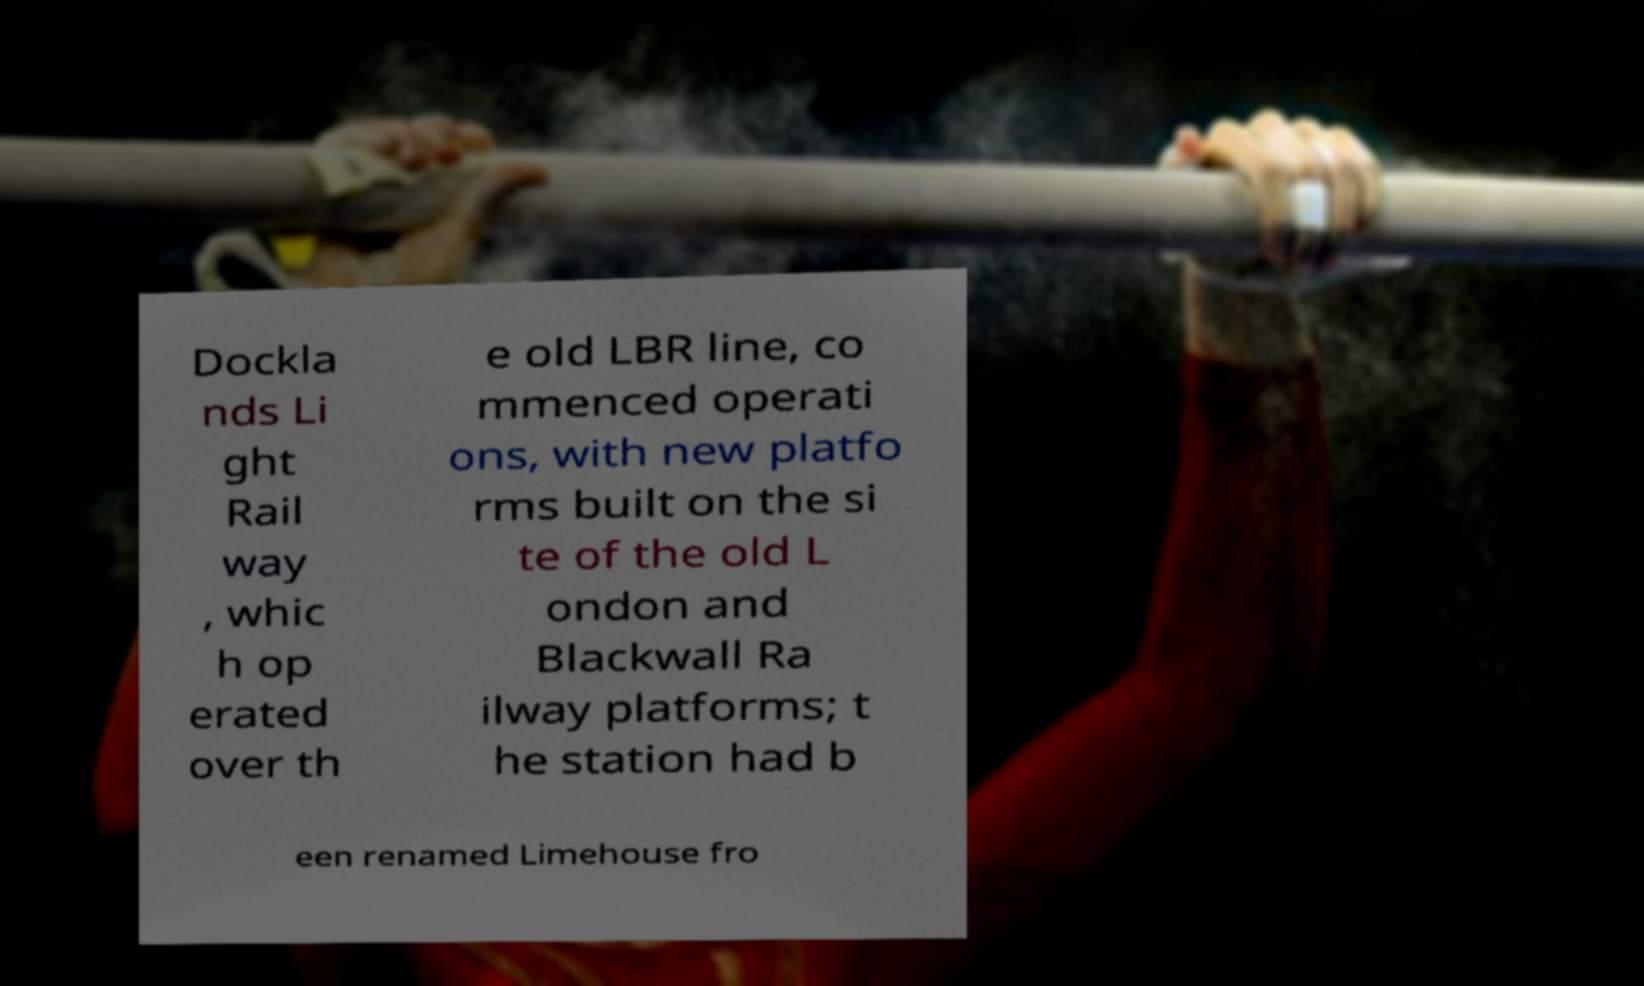Could you extract and type out the text from this image? Dockla nds Li ght Rail way , whic h op erated over th e old LBR line, co mmenced operati ons, with new platfo rms built on the si te of the old L ondon and Blackwall Ra ilway platforms; t he station had b een renamed Limehouse fro 